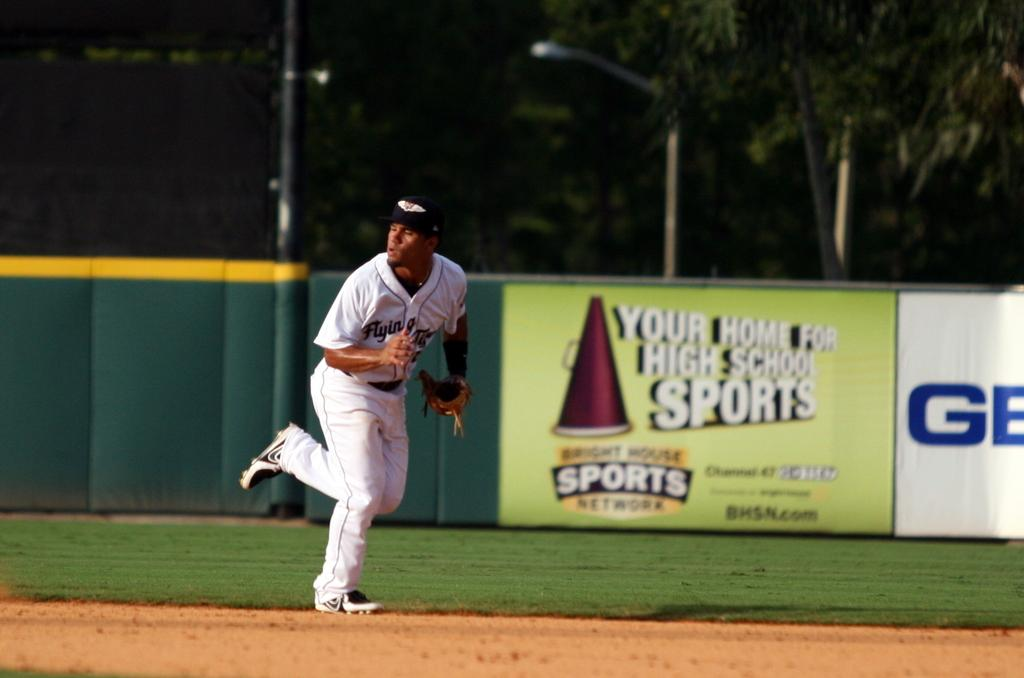<image>
Provide a brief description of the given image. A player is running in front of a Sports Network sign. 